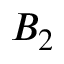<formula> <loc_0><loc_0><loc_500><loc_500>B _ { 2 }</formula> 